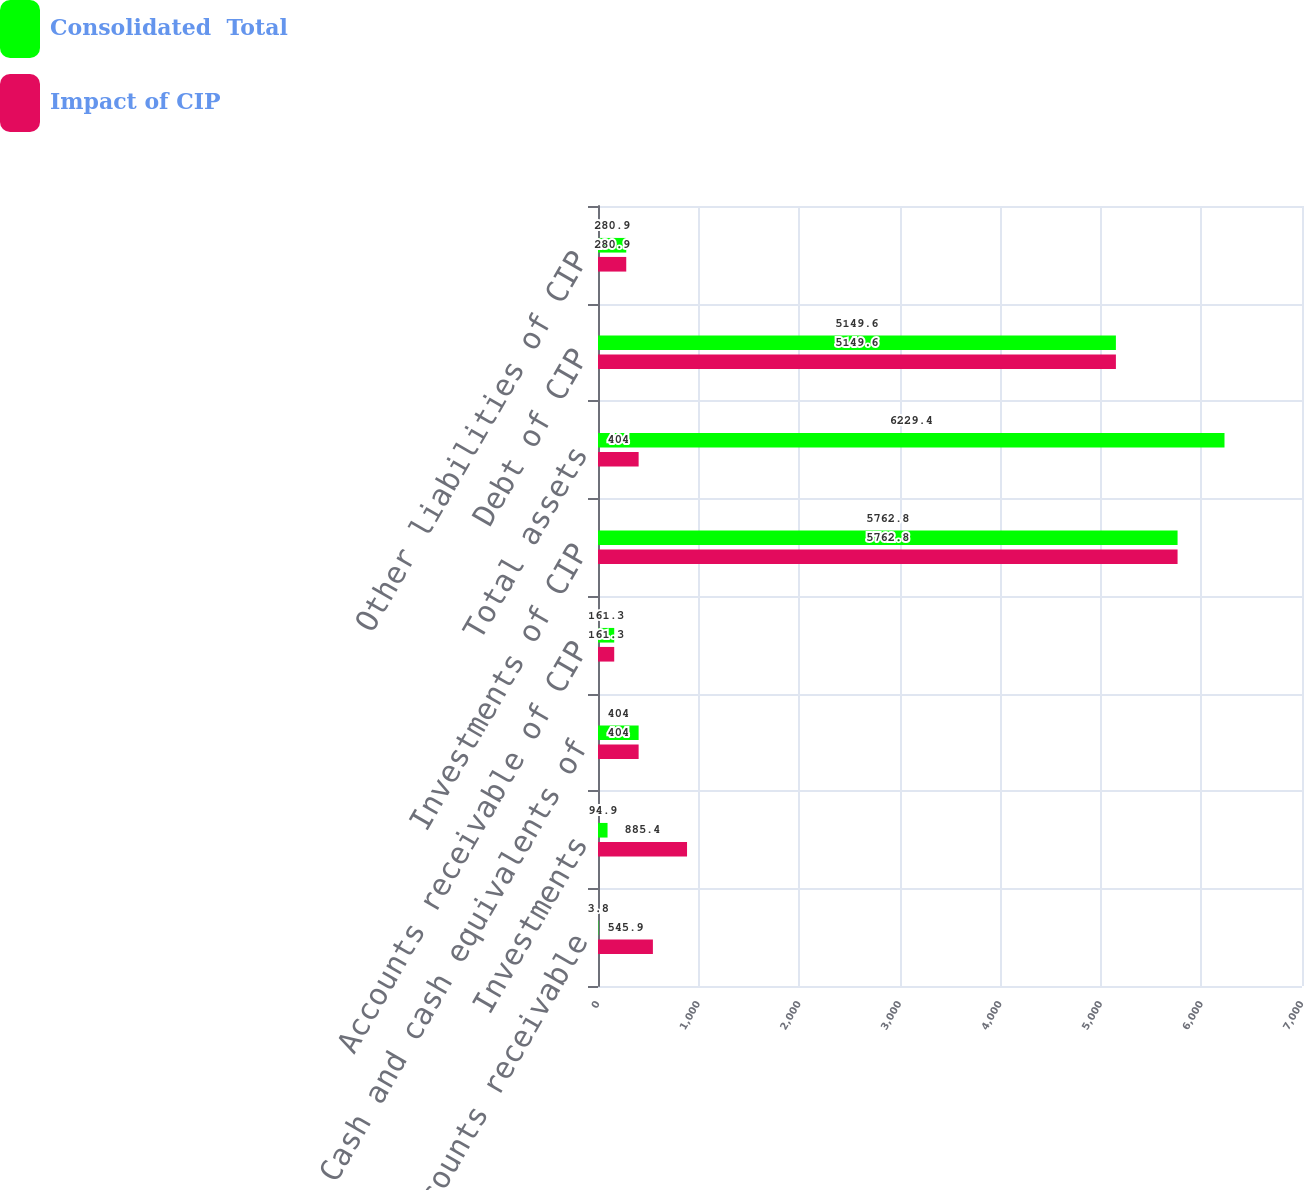<chart> <loc_0><loc_0><loc_500><loc_500><stacked_bar_chart><ecel><fcel>Accounts receivable<fcel>Investments<fcel>Cash and cash equivalents of<fcel>Accounts receivable of CIP<fcel>Investments of CIP<fcel>Total assets<fcel>Debt of CIP<fcel>Other liabilities of CIP<nl><fcel>Consolidated  Total<fcel>3.8<fcel>94.9<fcel>404<fcel>161.3<fcel>5762.8<fcel>6229.4<fcel>5149.6<fcel>280.9<nl><fcel>Impact of CIP<fcel>545.9<fcel>885.4<fcel>404<fcel>161.3<fcel>5762.8<fcel>404<fcel>5149.6<fcel>280.9<nl></chart> 